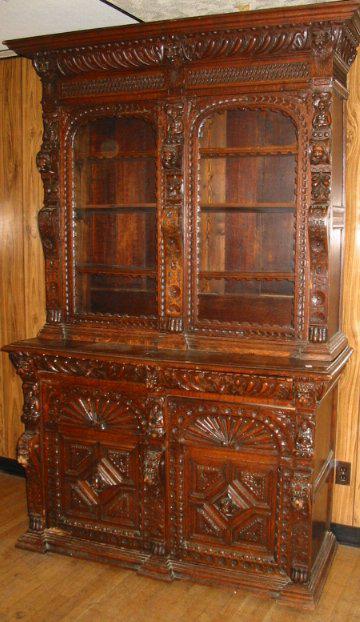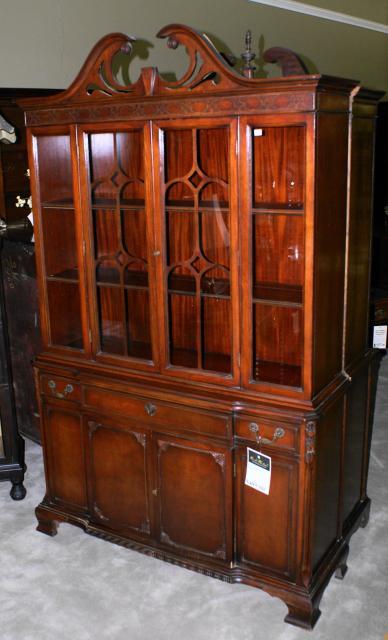The first image is the image on the left, the second image is the image on the right. Assess this claim about the two images: "Both images show just one cabinet with legs, and at least one cabinet has curving legs that end in a rounded foot.". Correct or not? Answer yes or no. No. The first image is the image on the left, the second image is the image on the right. Analyze the images presented: Is the assertion "All wooden displays feature clear glass and are completely empty." valid? Answer yes or no. Yes. 